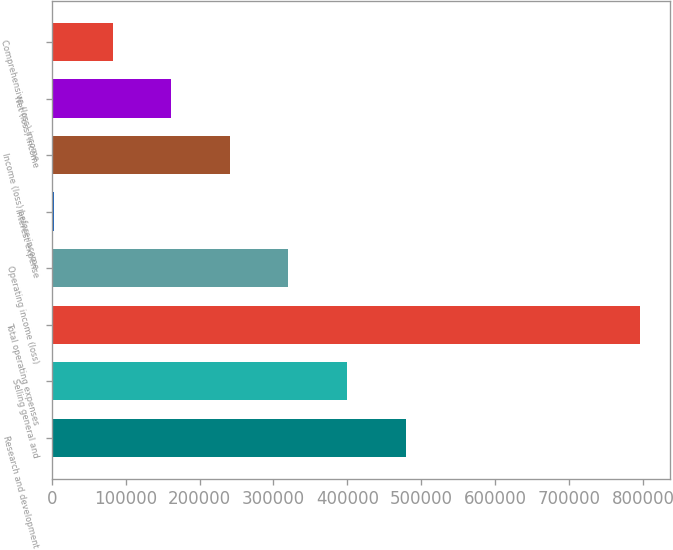Convert chart to OTSL. <chart><loc_0><loc_0><loc_500><loc_500><bar_chart><fcel>Research and development<fcel>Selling general and<fcel>Total operating expenses<fcel>Operating income (loss)<fcel>Interest expense<fcel>Income (loss) before income<fcel>Net (loss) income<fcel>Comprehensive (loss) income<nl><fcel>478906<fcel>399610<fcel>796090<fcel>320313<fcel>3129<fcel>241017<fcel>161721<fcel>82425.1<nl></chart> 